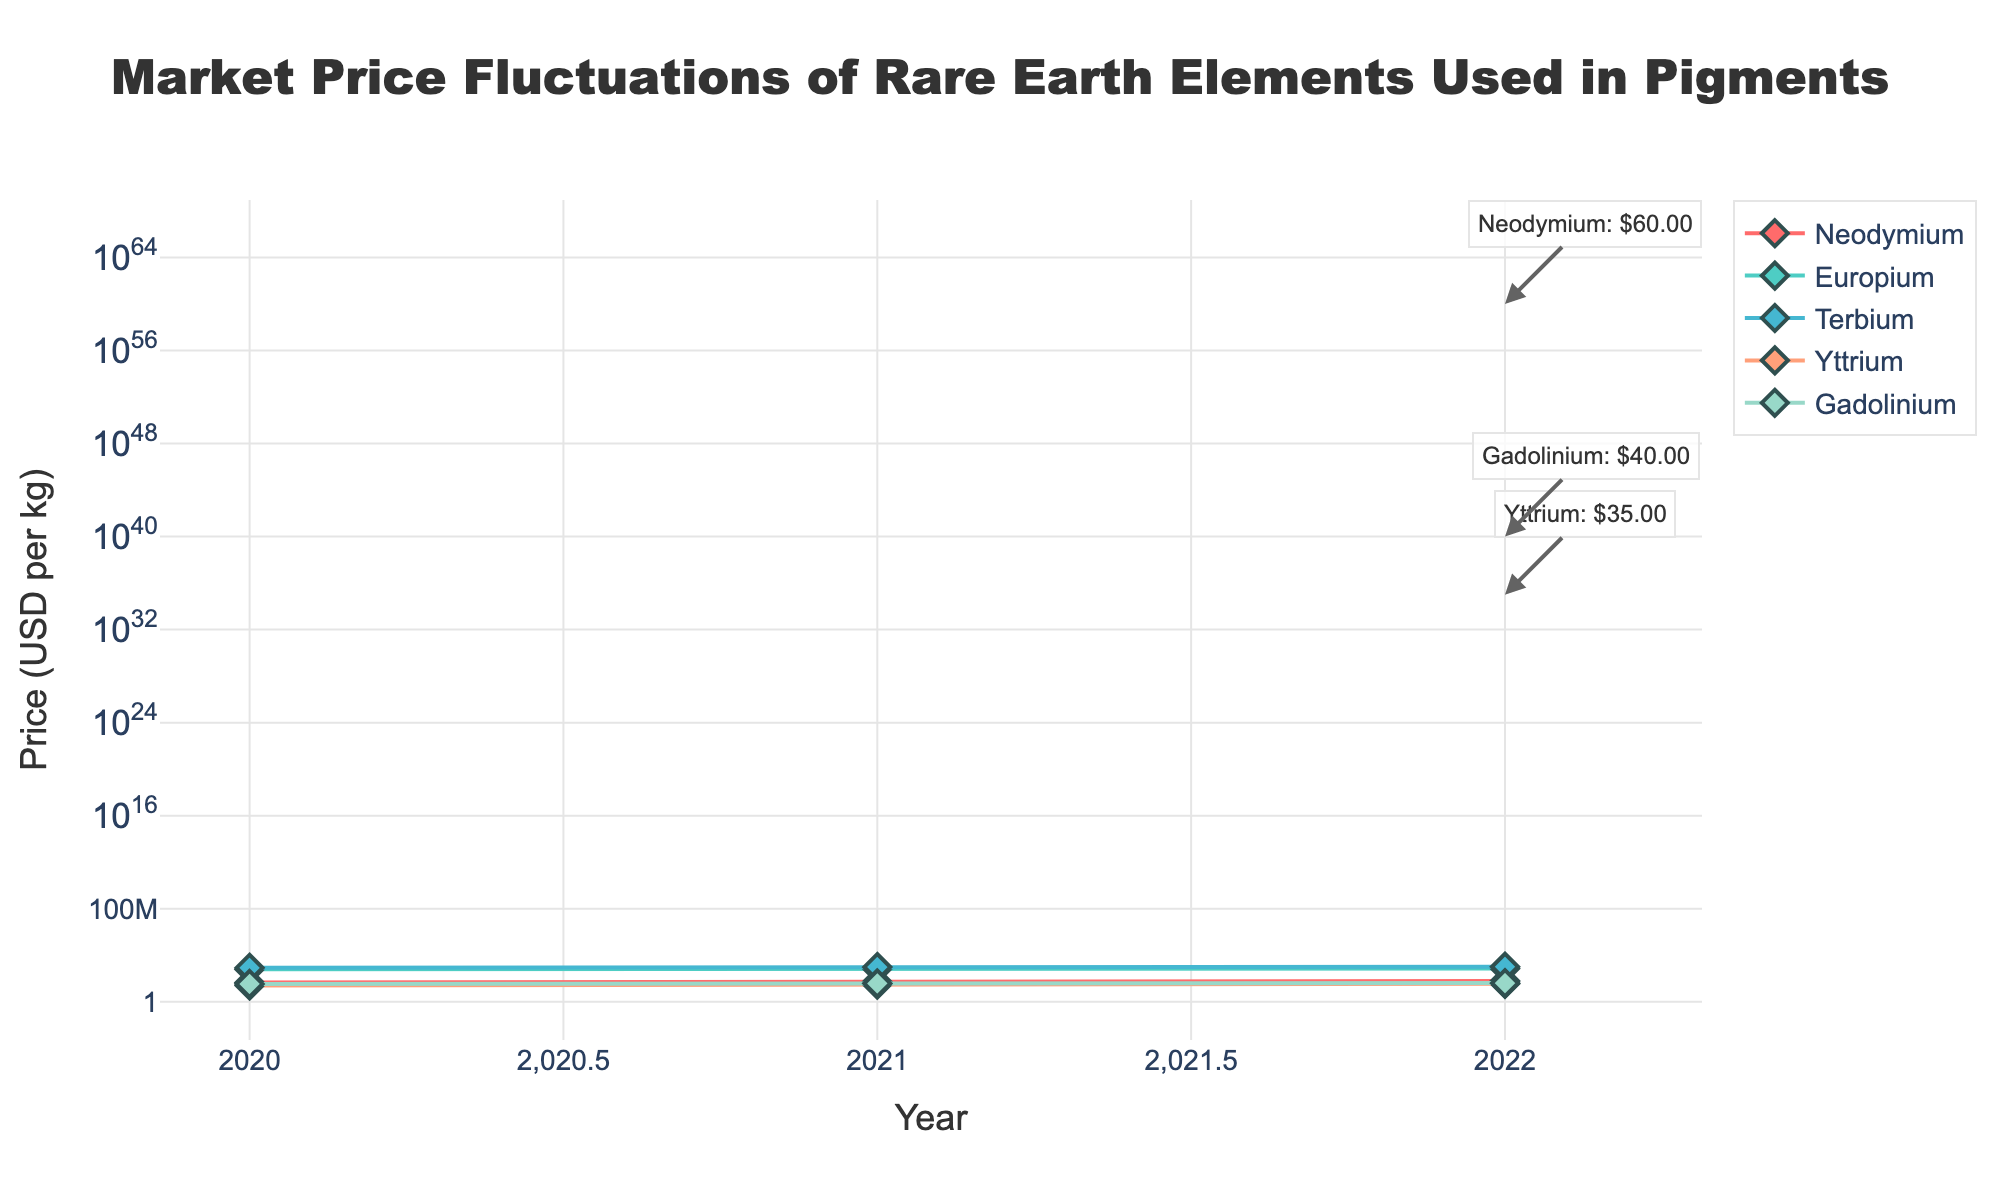What is the title of the figure? The title is displayed at the top center of the figure in a large font. Reading the title directly from the figure, it states "Market Price Fluctuations of Rare Earth Elements Used in Pigments".
Answer: Market Price Fluctuations of Rare Earth Elements Used in Pigments Which element had the highest price in 2022? By looking at the scatter plot, identify the data points for the year 2022 and compare their y-values (prices). The element with the highest price in 2022 is Terbium, with a price of 1020 USD per kg.
Answer: Terbium What is the price of Europium in 2021? Locate the data point for Europium in the year 2021 on the scatter plot. The y-value of this point represents the price. The price of Europium in 2021 is 680 USD per kg.
Answer: 680 USD per kg How many years of data are shown in the figure? Count the unique years displayed along the x-axis. The years shown are 2020, 2021, and 2022.
Answer: 3 Which element had the most significant price increase from 2020 to 2022? Calculate the price increase for each element by subtracting the 2020 price from the 2022 price. Neodymium increased from 45.0 to 60.0 (15.0 USD), Europium increased from 620.0 to 710.0 (90.0 USD), Terbium increased from 830.0 to 1020.0 (190.0 USD), Yttrium increased from 25.0 to 35.0 (10.0 USD), and Gadolinium increased from 34.0 to 40.0 (6.0 USD). Terbium had the most significant price increase of 190.0 USD.
Answer: Terbium What is the average price of Neodymium over the three years shown? To find the average price of Neodymium, sum the prices from 2020, 2021, and 2022 (45.0 + 53.0 + 60.0), which equals 158.0, and then divide by the number of years (3). The average price is 158.0/3 = 52.67 USD per kg.
Answer: 52.67 USD per kg Compare the price of Yttrium and Gadolinium in 2020. Which one is higher? Look at the y-values for Yttrium and Gadolinium in the year 2020. Yttrium is priced at 25.0 USD per kg, and Gadolinium is priced at 34.0 USD per kg. Gadolinium has a higher price than Yttrium in 2020.
Answer: Gadolinium In which year did Terbium have a price just below 1000 USD per kg? Locate Terbium's prices on the scatter plot. In 2021, the price of Terbium is 950 USD per kg, which is just below 1000 USD.
Answer: 2021 What is the overall trend of prices for Yttrium from 2020 to 2022? Examine the trajectory of Yttrium's data points over the years. The prices steadily increase from 25.0 USD per kg in 2020 to 30.0 USD per kg in 2021 and then to 35.0 USD per kg in 2022. The trend is an increasing price.
Answer: Increasing 